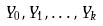Convert formula to latex. <formula><loc_0><loc_0><loc_500><loc_500>Y _ { 0 } , Y _ { 1 } , \dots , Y _ { k }</formula> 